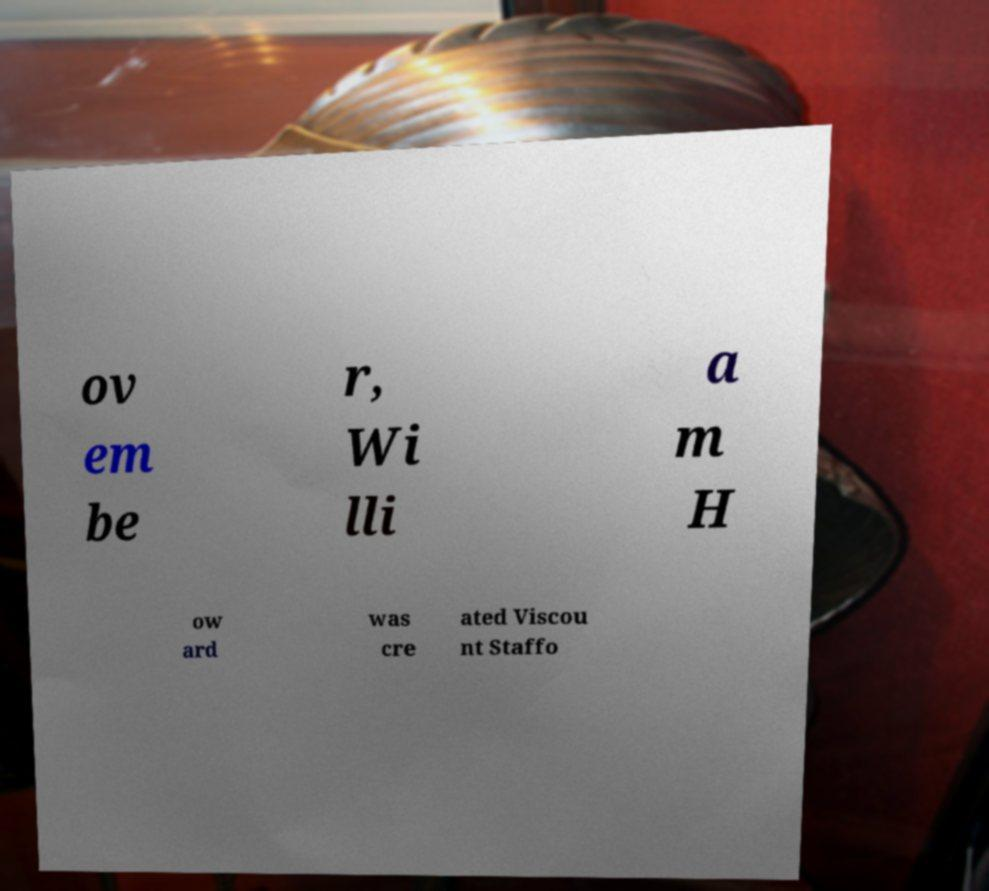What messages or text are displayed in this image? I need them in a readable, typed format. ov em be r, Wi lli a m H ow ard was cre ated Viscou nt Staffo 